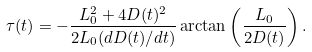<formula> <loc_0><loc_0><loc_500><loc_500>\tau ( t ) = - \frac { L _ { 0 } ^ { 2 } + 4 D ( t ) ^ { 2 } } { 2 L _ { 0 } ( d D ( t ) / d t ) } \arctan \left ( \frac { L _ { 0 } } { 2 D ( t ) } \right ) .</formula> 